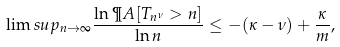Convert formula to latex. <formula><loc_0><loc_0><loc_500><loc_500>\lim s u p _ { n \to \infty } \frac { \ln \P A [ T _ { n ^ { \nu } } > n ] } { \ln n } \leq - ( \kappa - \nu ) + \frac { \kappa } m ,</formula> 